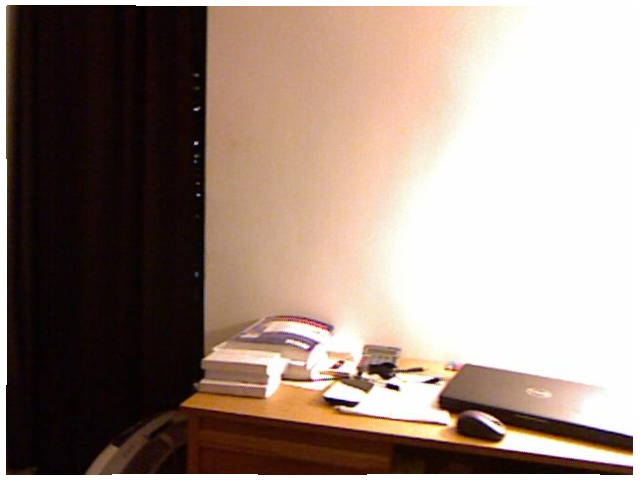<image>
Is there a laptop under the desk? No. The laptop is not positioned under the desk. The vertical relationship between these objects is different. 